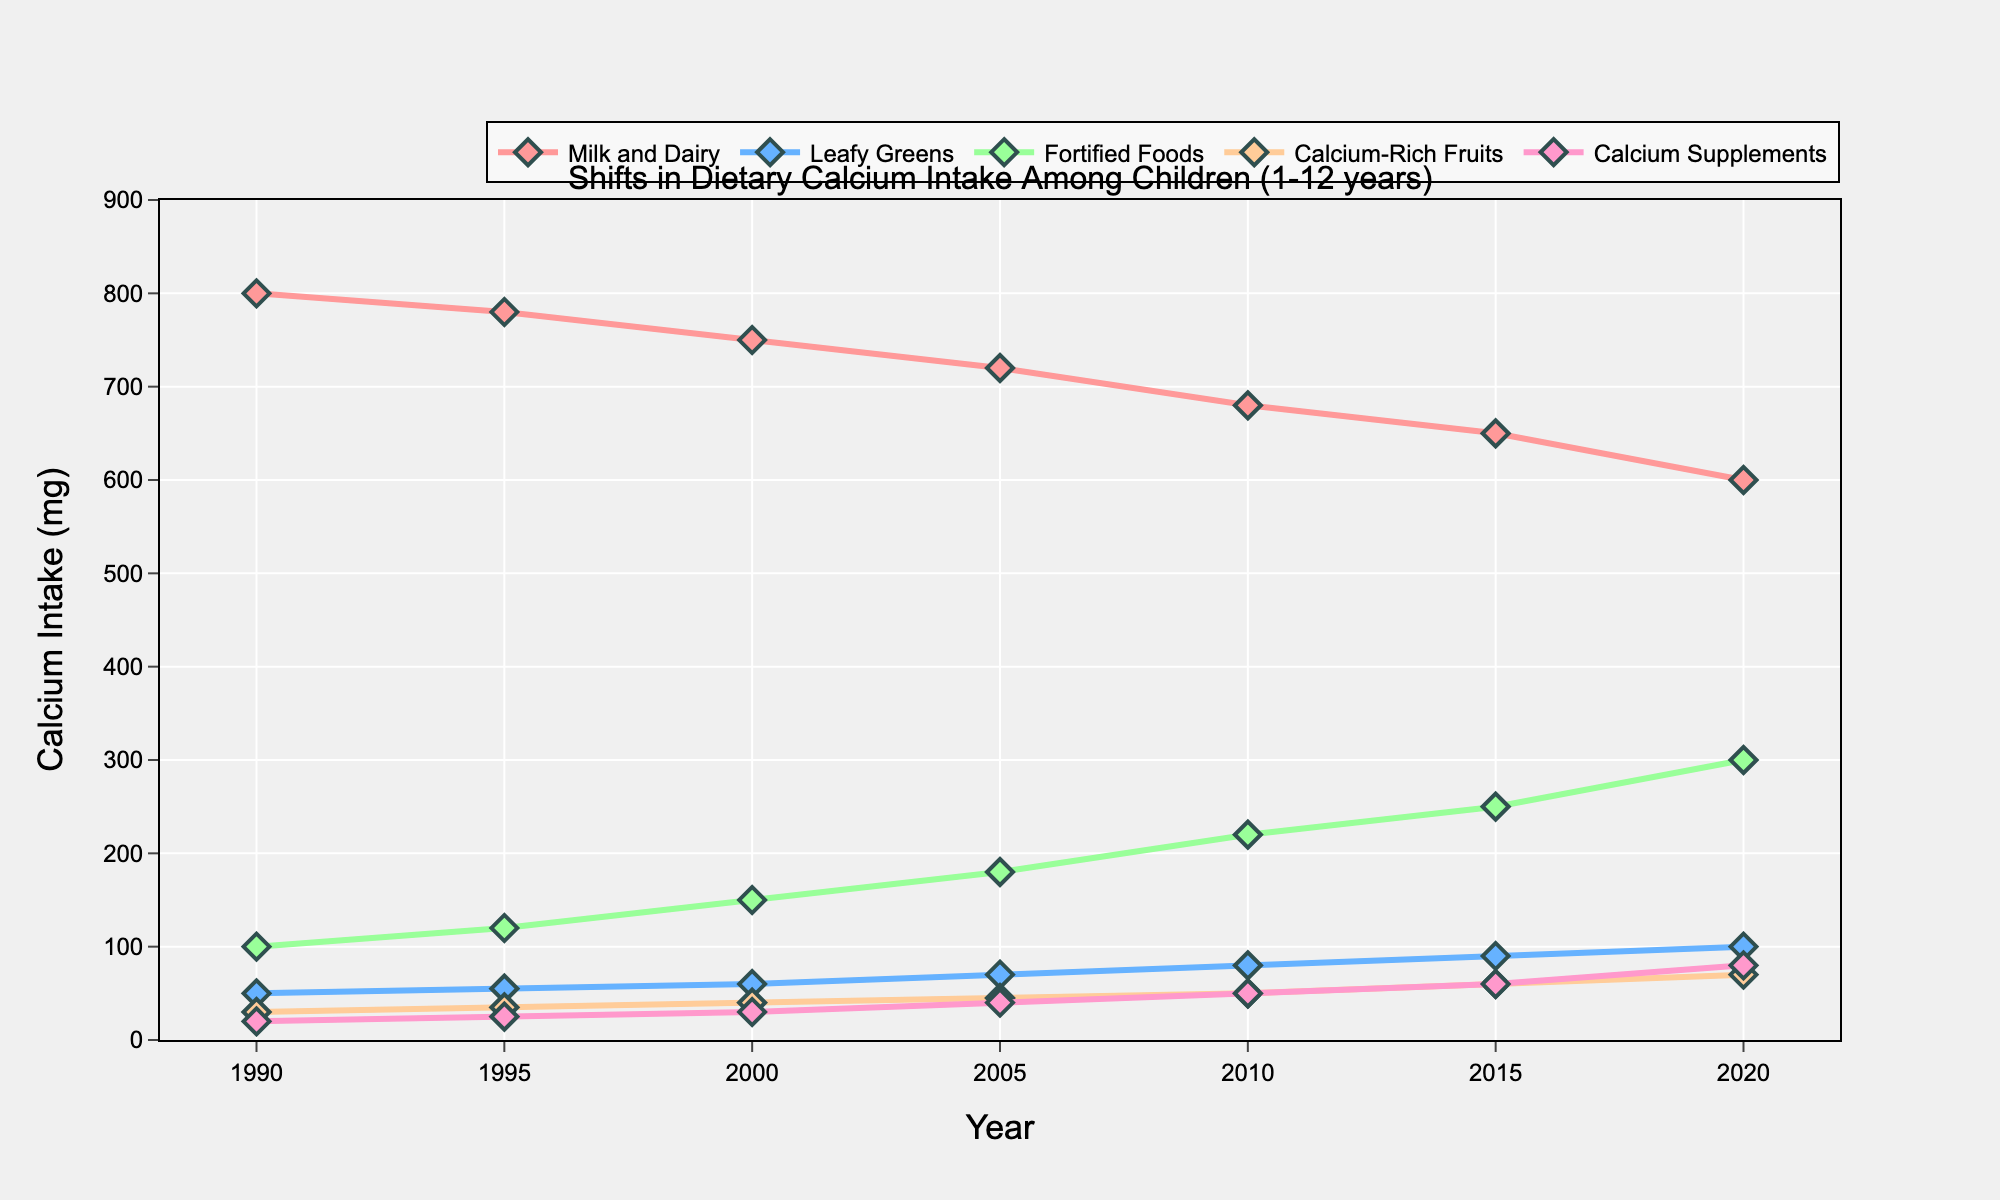What is the overall trend in calcium intake from milk and dairy between 1990 and 2020? Milk and dairy calcium intake shows a decreasing trend from 800 mg in 1990 to 600 mg in 2020.
Answer: Decreasing Which dietary source saw the greatest increase in calcium intake from 1990 to 2020? Calcium intake from fortified foods increased the most, from 100 mg in 1990 to 300 mg in 2020, an increase of 200 mg.
Answer: Fortified Foods Compare the calcium intake from leafy greens and calcium supplements in 2020. In 2020, calcium intake from leafy greens is 100 mg, while from calcium supplements it is 80 mg. Leafy greens have 20 mg more than calcium supplements.
Answer: Leafy greens have higher How did calcium intake from calcium-rich fruits change between 1990 and 2020? Calcium intake from calcium-rich fruits increased from 30 mg in 1990 to 70 mg in 2020.
Answer: Increased What's the combined calcium intake from milk and dairy, and fortified foods in 2010? In 2010, calcium intake from milk and dairy is 680 mg and from fortified foods is 220 mg. Combined, it is 680 + 220 = 900 mg.
Answer: 900 mg Which year shows the highest intake of calcium from calcium supplements? The highest intake of calcium from supplements is in 2020, with 80 mg.
Answer: 2020 Which dietary source had the smallest change in calcium intake from 1990 to 2020? Intake from calcium-rich fruits shows the smallest change, increasing from 30 mg in 1990 to 70 mg in 2020, an increase of 40 mg.
Answer: Calcium-rich fruits What is the total calcium intake from leafy greens over the years 1990, 2000, and 2020? Calcium intake from leafy greens in 1990, 2000, and 2020 are 50 mg, 60 mg, and 100 mg respectively. The total is 50 + 60 + 100 = 210 mg.
Answer: 210 mg 